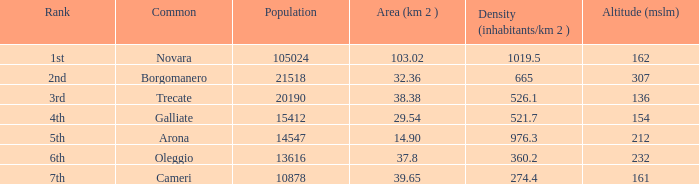In terms of population, what is the ranking of galliate common? 4th. Give me the full table as a dictionary. {'header': ['Rank', 'Common', 'Population', 'Area (km 2 )', 'Density (inhabitants/km 2 )', 'Altitude (mslm)'], 'rows': [['1st', 'Novara', '105024', '103.02', '1019.5', '162'], ['2nd', 'Borgomanero', '21518', '32.36', '665', '307'], ['3rd', 'Trecate', '20190', '38.38', '526.1', '136'], ['4th', 'Galliate', '15412', '29.54', '521.7', '154'], ['5th', 'Arona', '14547', '14.90', '976.3', '212'], ['6th', 'Oleggio', '13616', '37.8', '360.2', '232'], ['7th', 'Cameri', '10878', '39.65', '274.4', '161']]} 